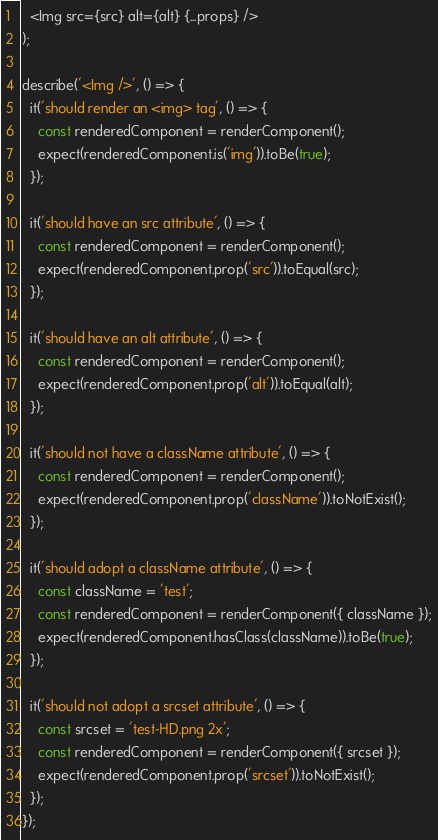<code> <loc_0><loc_0><loc_500><loc_500><_JavaScript_>  <Img src={src} alt={alt} {...props} />
);

describe('<Img />', () => {
  it('should render an <img> tag', () => {
    const renderedComponent = renderComponent();
    expect(renderedComponent.is('img')).toBe(true);
  });

  it('should have an src attribute', () => {
    const renderedComponent = renderComponent();
    expect(renderedComponent.prop('src')).toEqual(src);
  });

  it('should have an alt attribute', () => {
    const renderedComponent = renderComponent();
    expect(renderedComponent.prop('alt')).toEqual(alt);
  });

  it('should not have a className attribute', () => {
    const renderedComponent = renderComponent();
    expect(renderedComponent.prop('className')).toNotExist();
  });

  it('should adopt a className attribute', () => {
    const className = 'test';
    const renderedComponent = renderComponent({ className });
    expect(renderedComponent.hasClass(className)).toBe(true);
  });

  it('should not adopt a srcset attribute', () => {
    const srcset = 'test-HD.png 2x';
    const renderedComponent = renderComponent({ srcset });
    expect(renderedComponent.prop('srcset')).toNotExist();
  });
});
</code> 